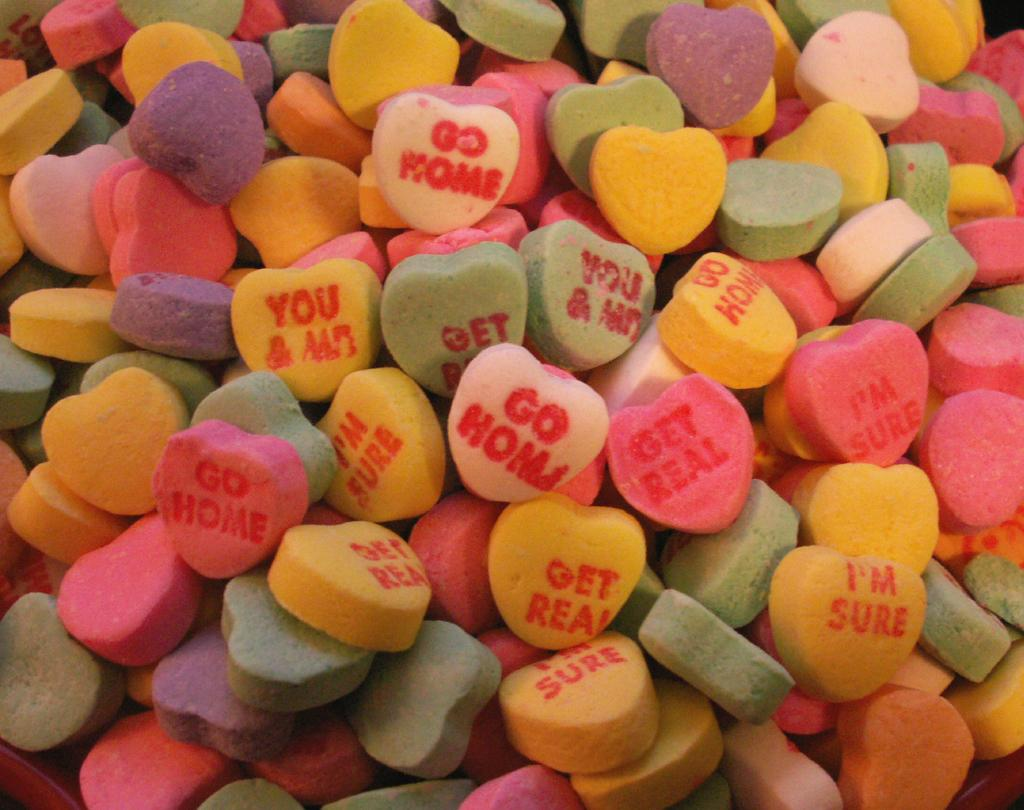What type of candy is featured in the image? There are colorful heart-shaped candy's in the image. Are there any words or letters on the candy's? Yes, there are letters on some of the candy's. What type of record can be seen spinning on a turntable in the image? There is no record or turntable present in the image; it features colorful heart-shaped candy's with letters on some of them. Can you see a kitty playing with the candy's in the image? There is no kitty present in the image. 